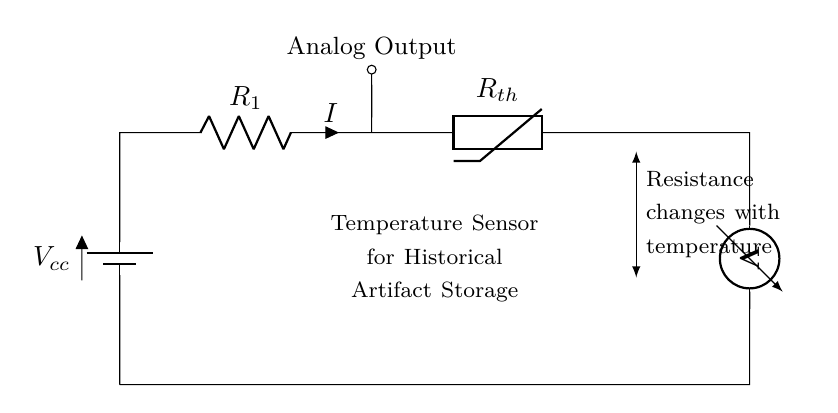What is the main purpose of this circuit? The main purpose of the circuit is to monitor temperature conditions in order to protect historical artifacts from damage due to improper storage conditions.
Answer: Monitor historical artifact temperature What type of sensor is used in this circuit? The circuit uses a thermistor, which is a temperature-dependent resistor that changes its resistance with temperature variations.
Answer: Thermistor Which component generates the current in the circuit? The battery generates the current, providing the necessary voltage for the circuit operation.
Answer: Battery What does the analog output indicate? The analog output provides a voltage signal proportional to the temperature being measured, allowing for monitoring of the environmental condition.
Answer: Voltage signal How does the resistance of the thermistor change? The resistance of the thermistor decreases with increasing temperature, allowing it to measure varying temperature levels effectively.
Answer: Decreases with temperature What is the function of the resistor in this circuit? The resistor serves to limit the current flowing through the circuit, ensuring safe operation and preventing damage to the thermistor and other components.
Answer: Limit current What is the significance of the short connection in this circuit? The short connection here helps complete the circuit, allowing current to flow from the battery through the resistor and thermistor, enabling temperature measurement.
Answer: Completes the circuit 